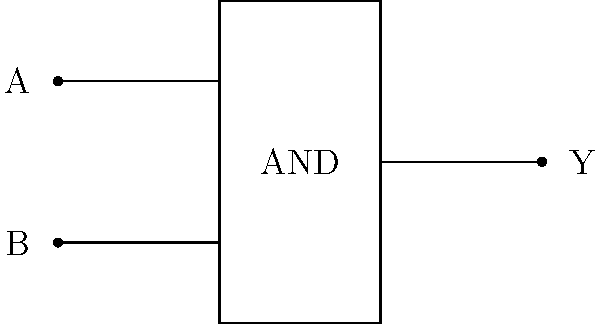As a fashion brand representative, you're exploring innovative ways to create textile patterns. You come across a logic gate diagram that could inspire a unique weaving pattern. The diagram shows an AND gate with inputs A and B, and output Y. How would you interpret this gate's functionality to create a textile pattern where the presence of both input threads (A and B) results in a distinctive output thread (Y)? To interpret the AND gate functionality for a textile pattern:

1. Understand the AND gate: The output Y is true (1) only when both inputs A and B are true (1).

2. Translate to textile terms:
   - Input A: Represent as one type of thread (e.g., silk)
   - Input B: Represent as another type of thread (e.g., cotton)
   - Output Y: Represent as a combined or special thread

3. Create weaving rules:
   - When both A and B threads are present in a section, introduce the special Y thread.
   - If either A or B is missing, do not use the Y thread.

4. Design pattern:
   - Create a grid representing the fabric.
   - Place A and B threads according to your desired base pattern.
   - Wherever A and B intersect, introduce the Y thread.

5. Enhance complexity:
   - Use different colors for A, B, and Y to create visual interest.
   - Vary thread thickness to add texture.

6. Implement in weaving:
   - Program the loom or guide manual weaving to follow this logic-inspired pattern.

This interpretation creates a unique textile where the special Y thread appears only in areas where both A and B threads are present, mimicking the AND gate's behavior in a fabric design.
Answer: Introduce special thread Y where threads A and B intersect 